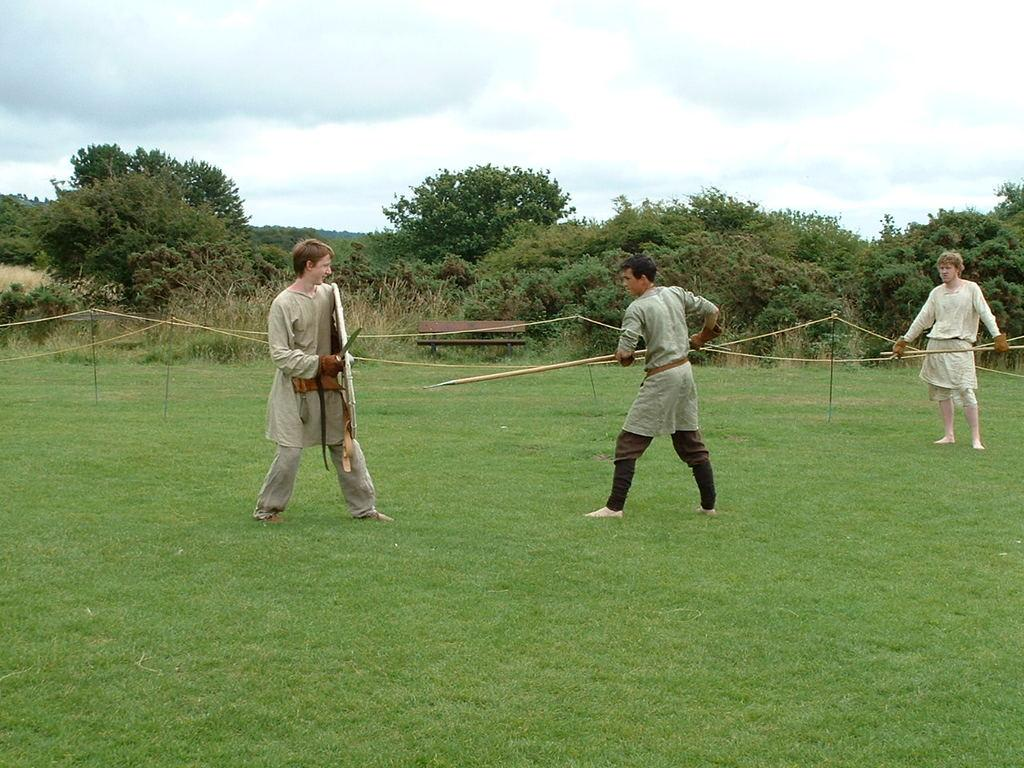What type of vegetation is present in the image? There is green grass in the image. What are the people holding in the image? The people are holding weapons in the image. What other natural elements can be seen in the image? There are trees in the image. What is visible in the sky in the image? There are clouds visible in the sky. What type of liquid is being used by the people holding weapons in the image? There is no liquid mentioned or visible in the image; the people are holding weapons. How many times do the trees sneeze in the image? Trees do not sneeze, as they are inanimate objects. 